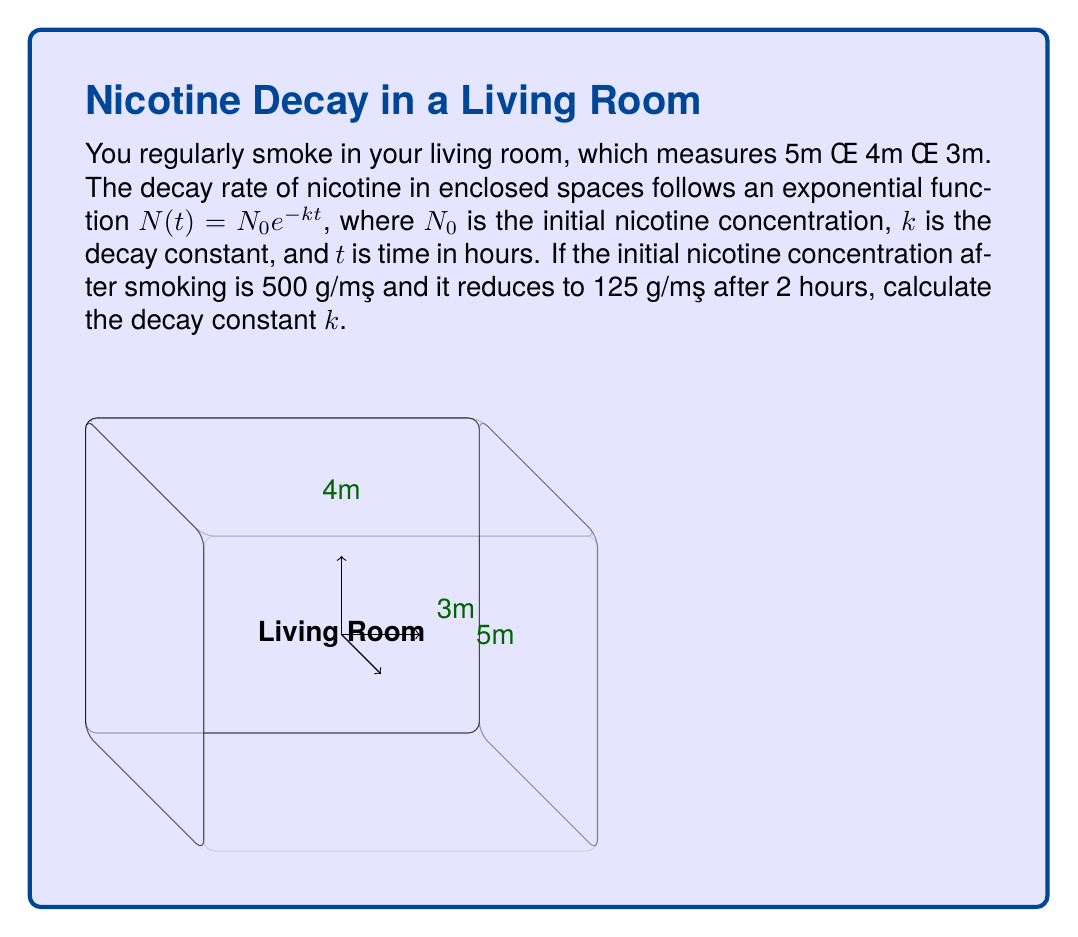Teach me how to tackle this problem. Let's approach this step-by-step:

1) We are given the exponential decay function:
   $N(t) = N_0 e^{-kt}$

2) We know:
   - Initial concentration $N_0 = 500$ μg/m³
   - Concentration after 2 hours $N(2) = 125$ μg/m³
   - Time $t = 2$ hours

3) Let's substitute these values into the equation:
   $125 = 500 e^{-k(2)}$

4) Divide both sides by 500:
   $\frac{125}{500} = e^{-2k}$

5) Simplify:
   $0.25 = e^{-2k}$

6) Take the natural logarithm of both sides:
   $\ln(0.25) = -2k$

7) Solve for $k$:
   $k = -\frac{\ln(0.25)}{2}$

8) Calculate:
   $k = -\frac{\ln(0.25)}{2} = \frac{\ln(4)}{2} \approx 0.6931$ per hour

Therefore, the decay constant $k$ is approximately 0.6931 per hour.
Answer: $k \approx 0.6931$ per hour 